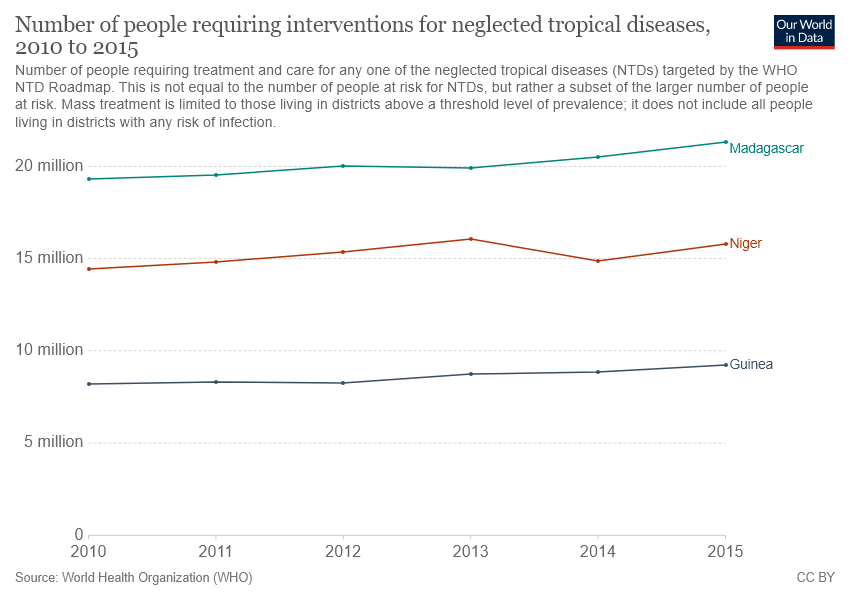Identify some key points in this picture. There are 3 items included in the chart. In 2010, the value of Niger was larger than the average value of Madagascar and Guinea. 